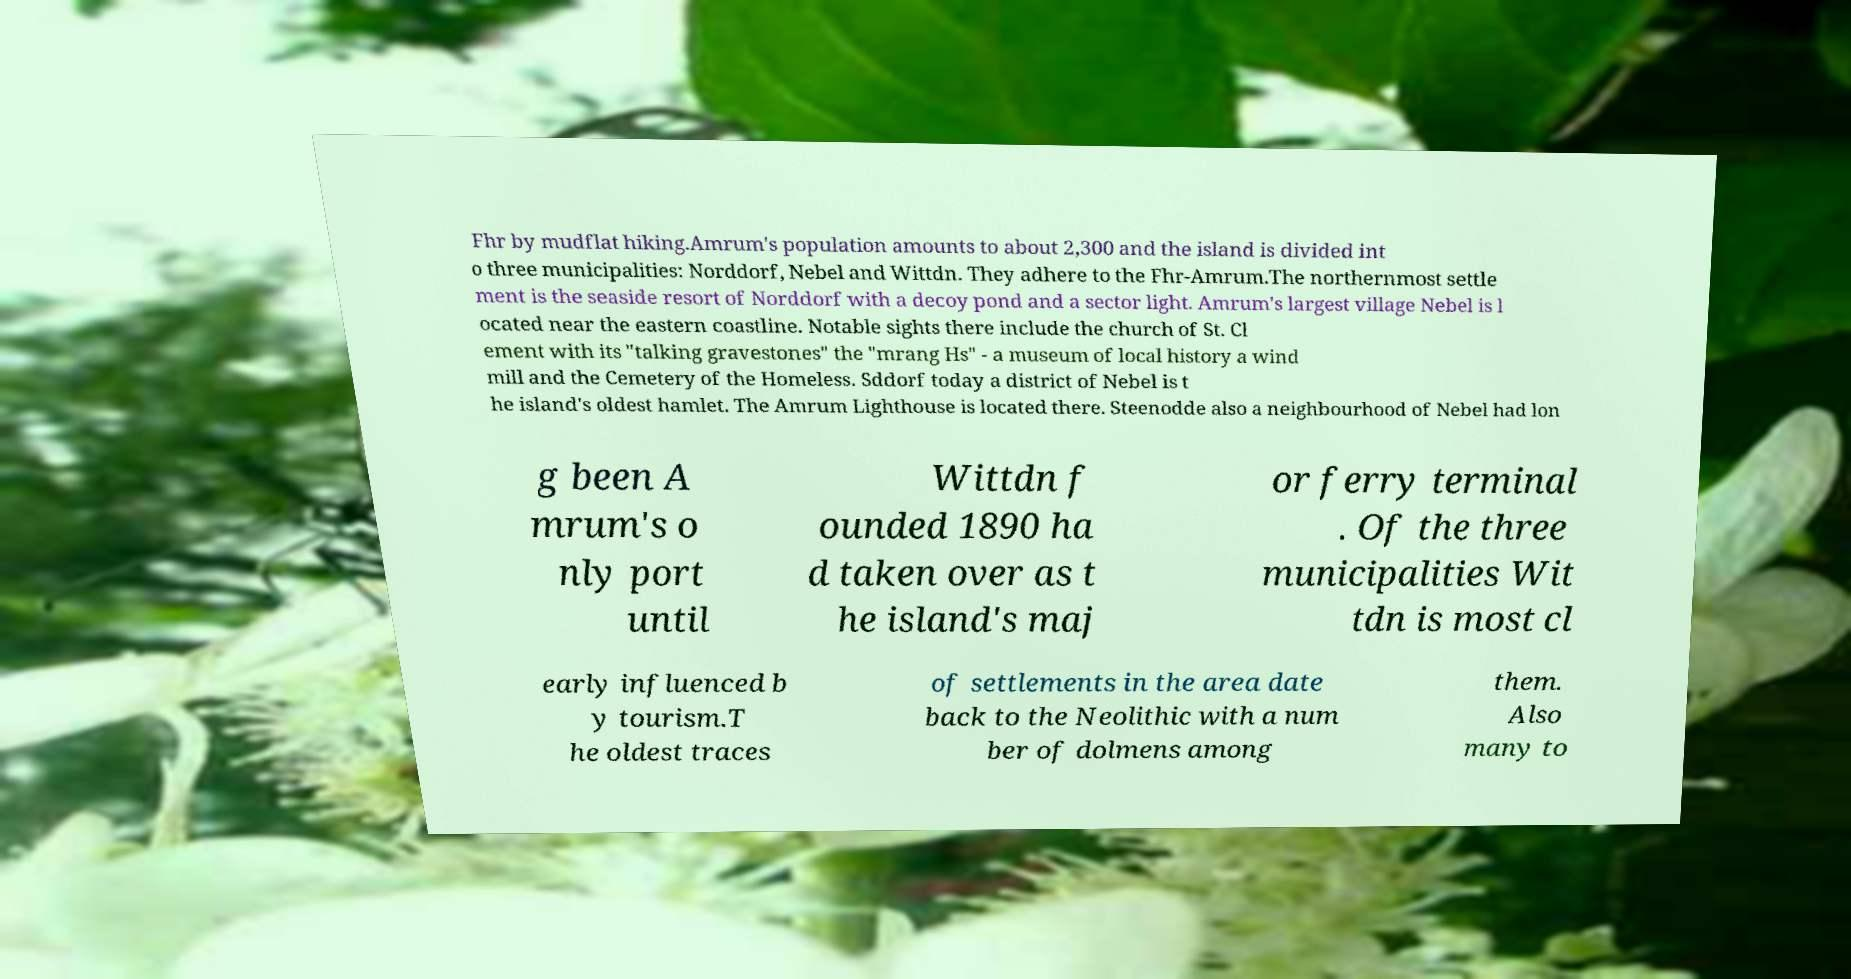Can you accurately transcribe the text from the provided image for me? Fhr by mudflat hiking.Amrum's population amounts to about 2,300 and the island is divided int o three municipalities: Norddorf, Nebel and Wittdn. They adhere to the Fhr-Amrum.The northernmost settle ment is the seaside resort of Norddorf with a decoy pond and a sector light. Amrum's largest village Nebel is l ocated near the eastern coastline. Notable sights there include the church of St. Cl ement with its "talking gravestones" the "mrang Hs" - a museum of local history a wind mill and the Cemetery of the Homeless. Sddorf today a district of Nebel is t he island's oldest hamlet. The Amrum Lighthouse is located there. Steenodde also a neighbourhood of Nebel had lon g been A mrum's o nly port until Wittdn f ounded 1890 ha d taken over as t he island's maj or ferry terminal . Of the three municipalities Wit tdn is most cl early influenced b y tourism.T he oldest traces of settlements in the area date back to the Neolithic with a num ber of dolmens among them. Also many to 